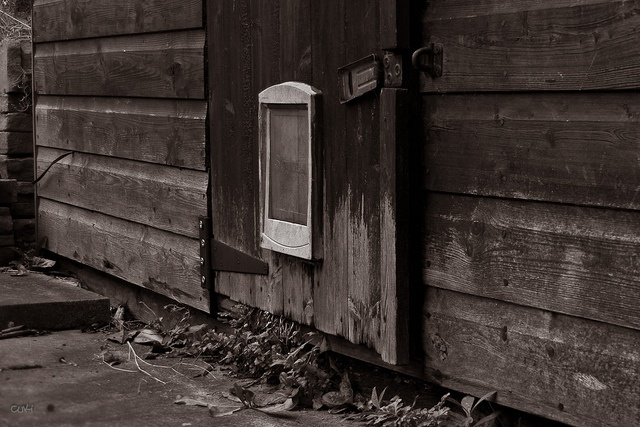Describe the objects in this image and their specific colors. I can see bird in gray, black, and darkgray tones and bird in gray, black, and darkgray tones in this image. 